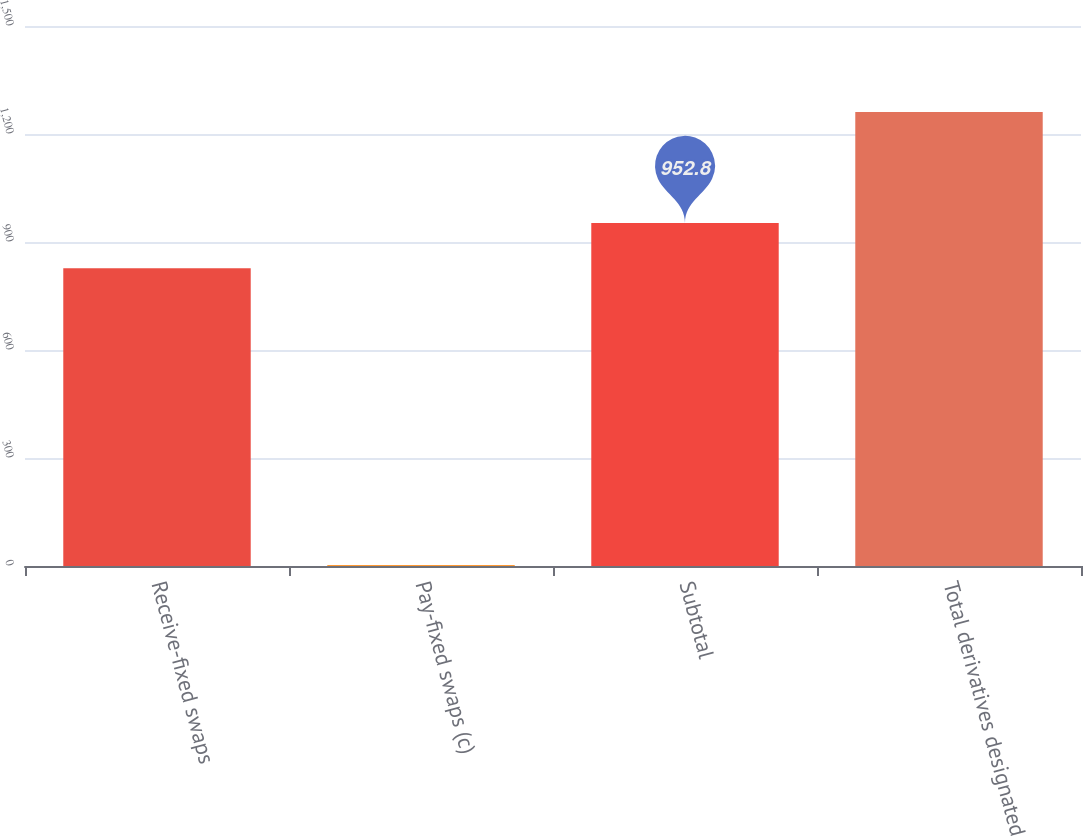Convert chart. <chart><loc_0><loc_0><loc_500><loc_500><bar_chart><fcel>Receive-fixed swaps<fcel>Pay-fixed swaps (c)<fcel>Subtotal<fcel>Total derivatives designated<nl><fcel>827<fcel>3<fcel>952.8<fcel>1261<nl></chart> 